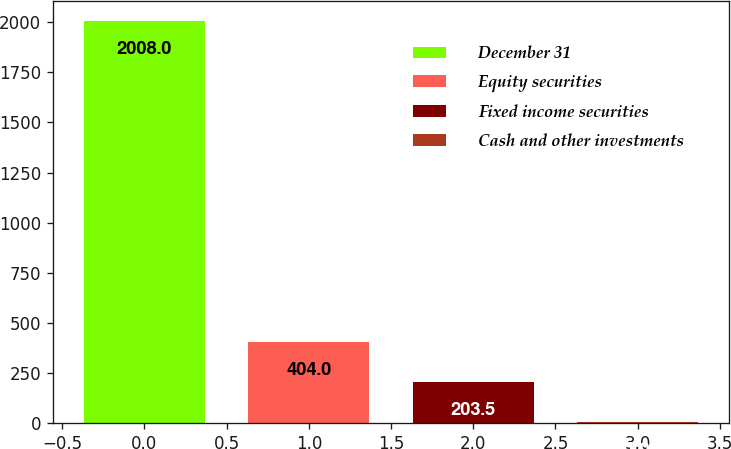Convert chart. <chart><loc_0><loc_0><loc_500><loc_500><bar_chart><fcel>December 31<fcel>Equity securities<fcel>Fixed income securities<fcel>Cash and other investments<nl><fcel>2008<fcel>404<fcel>203.5<fcel>3<nl></chart> 